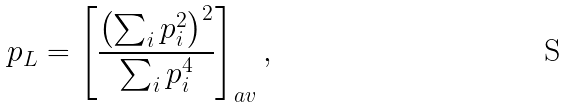<formula> <loc_0><loc_0><loc_500><loc_500>p _ { L } = \left [ \frac { \left ( \sum _ { i } p _ { i } ^ { 2 } \right ) ^ { 2 } } { \sum _ { i } p _ { i } ^ { 4 } } \right ] _ { a v } ,</formula> 